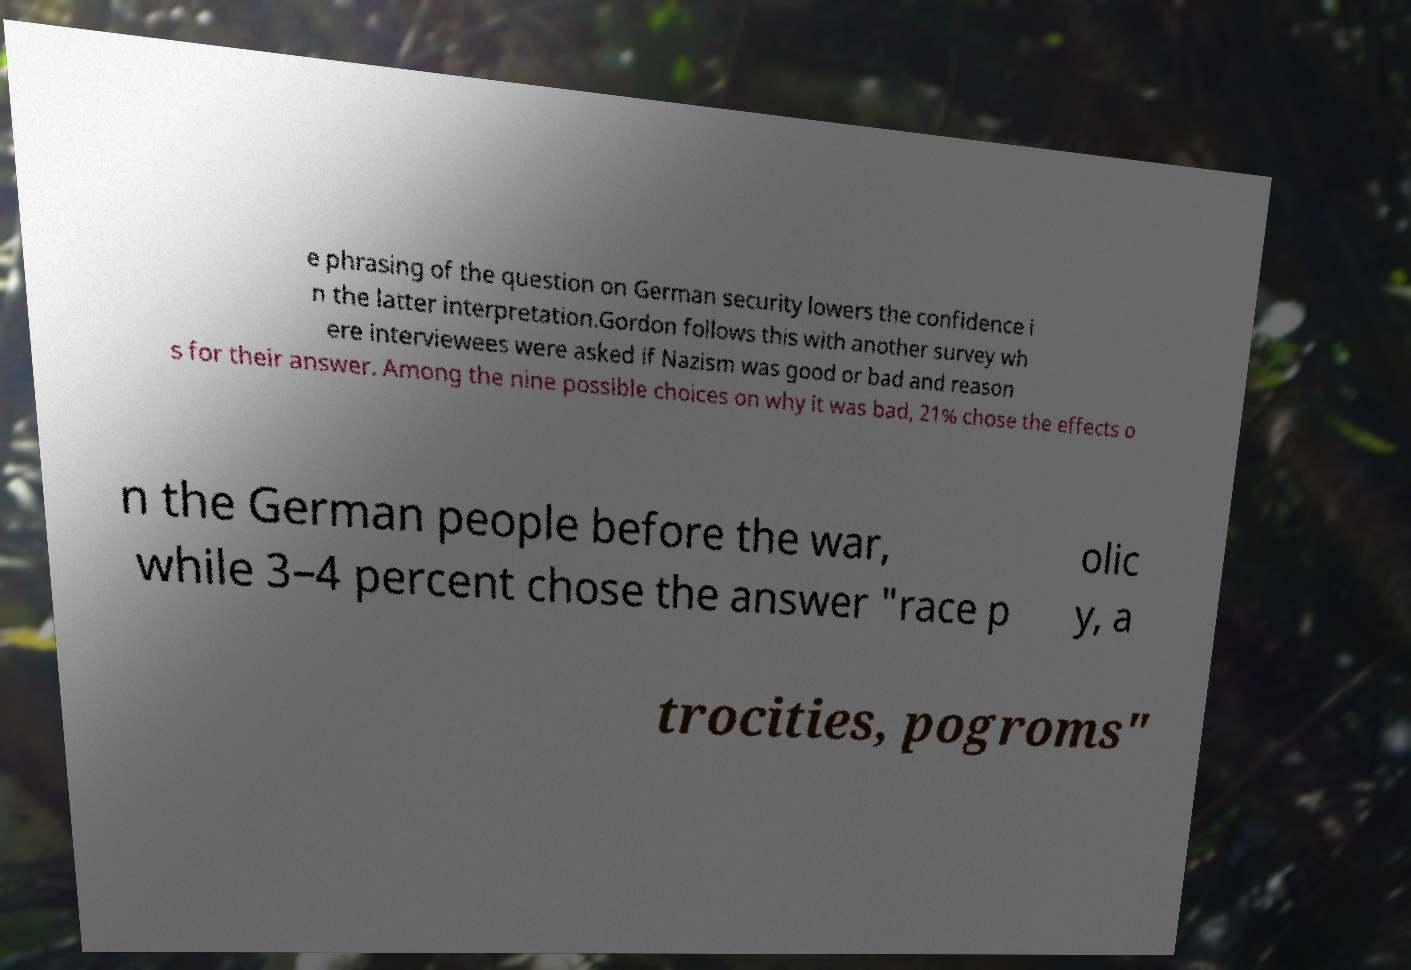There's text embedded in this image that I need extracted. Can you transcribe it verbatim? e phrasing of the question on German security lowers the confidence i n the latter interpretation.Gordon follows this with another survey wh ere interviewees were asked if Nazism was good or bad and reason s for their answer. Among the nine possible choices on why it was bad, 21% chose the effects o n the German people before the war, while 3–4 percent chose the answer "race p olic y, a trocities, pogroms" 